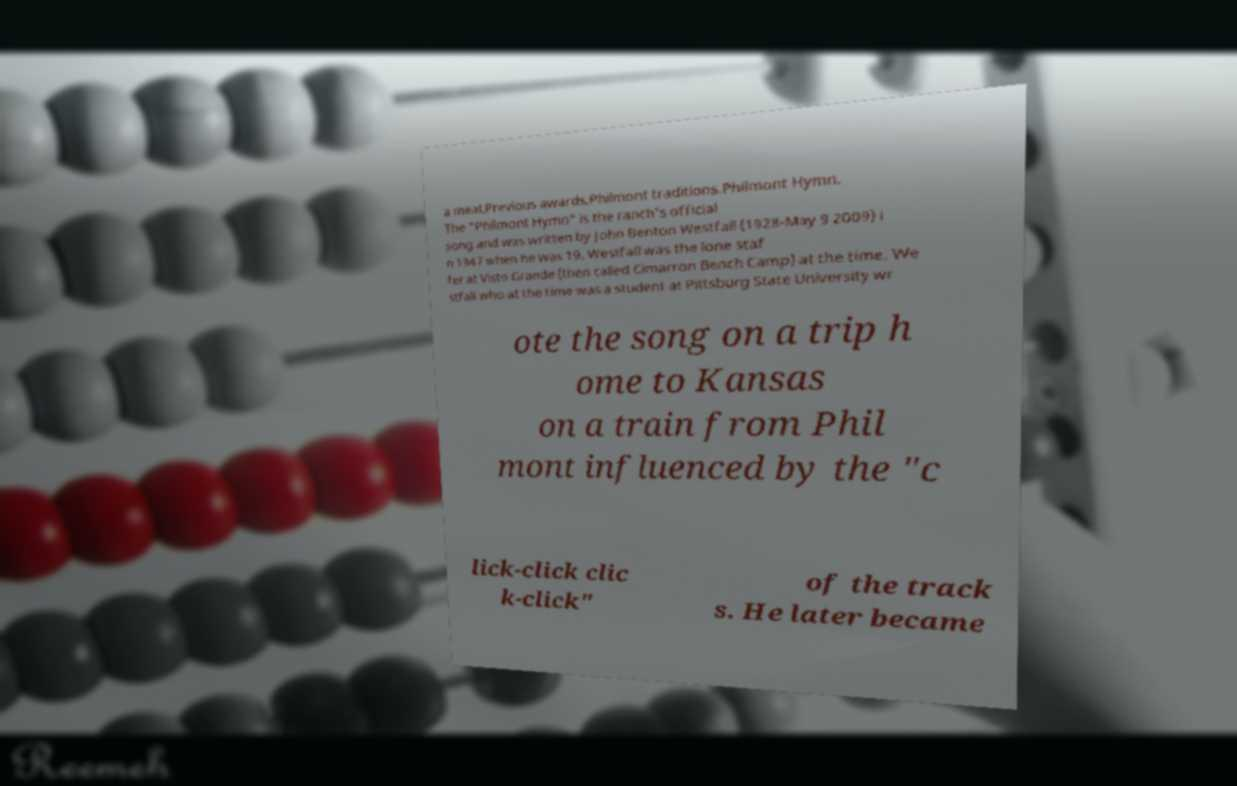Could you extract and type out the text from this image? a meal.Previous awards.Philmont traditions.Philmont Hymn. The "Philmont Hymn" is the ranch's official song and was written by John Benton Westfall (1928-May 9 2009) i n 1947 when he was 19. Westfall was the lone staf fer at Visto Grande (then called Cimarron Bench Camp) at the time. We stfall who at the time was a student at Pittsburg State University wr ote the song on a trip h ome to Kansas on a train from Phil mont influenced by the "c lick-click clic k-click" of the track s. He later became 